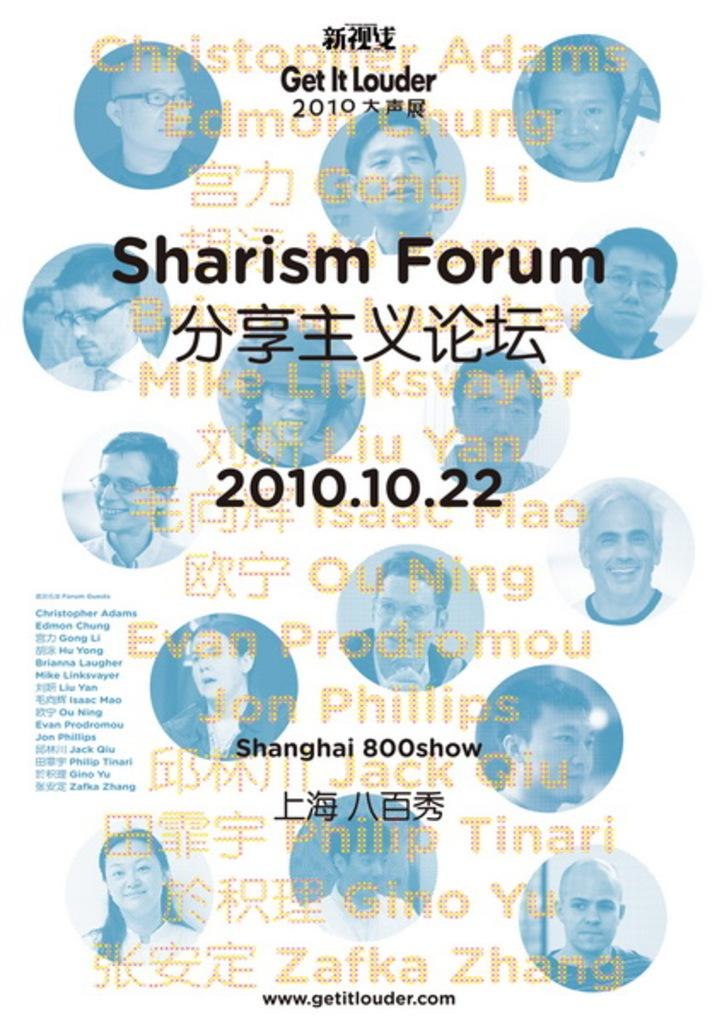What is the main subject in the image? There is a poster in the image. What can be seen in the pictures on the poster? The pictures on the poster contain images of many people. What else is featured on the poster besides the pictures? There is text on the poster. What scientific discovery is being made by the people in the poster? There is no indication of a scientific discovery in the poster; it simply contains pictures of many people and text. 